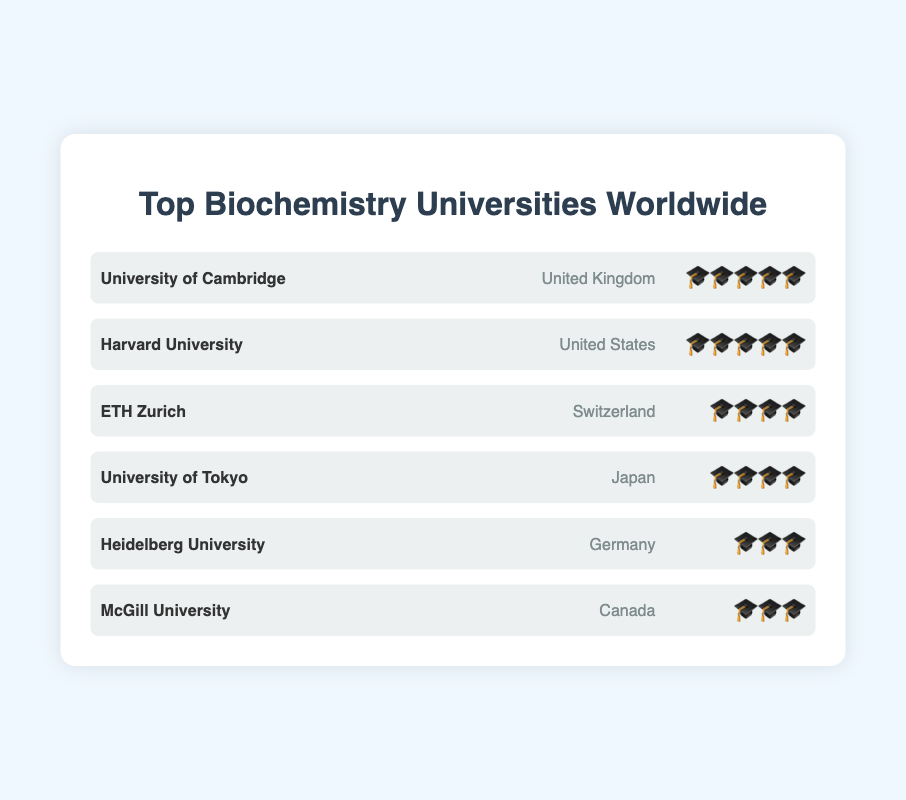Which universities have the highest rating in the chart? The chart shows two universities, University of Cambridge and Harvard University, each with a rating of 🎓🎓🎓🎓🎓. These universities have the highest ratings.
Answer: University of Cambridge and Harvard University Which university has the lowest rating on the chart? The chart indicates that both Heidelberg University and McGill University have a rating of 🎓🎓🎓. No universities have fewer graduation caps, making these the lowest-rated.
Answer: Heidelberg University and McGill University Which countries are represented by the top-rated universities? The top-rated universities, with 🎓🎓🎓🎓🎓, are University of Cambridge and Harvard University. Looking at their country labels, the United Kingdom and United States are represented.
Answer: United Kingdom and United States Which university from Japan is included in the chart, and what is its rating? The chart lists the University of Tokyo as the university from Japan. Its rating is displayed with four graduation caps 🎓🎓🎓🎓.
Answer: University of Tokyo, 🎓🎓🎓🎓 How many universities are shown on the chart in total? By counting each university row listed in the chart, there are six universities in total.
Answer: Six Which universities have a 4-graduation-cap rating? The chart shows two universities, ETH Zurich and University of Tokyo, each with a rating of 🎓🎓🎓🎓.
Answer: ETH Zurich and University of Tokyo Which country has the most universities listed in the chart? Each country listed has one university in the chart. There is no country with more than one university listed.
Answer: None How many universities have more than three graduation caps? By examining the graduation caps next to each university, four universities have more than three caps: University of Cambridge, Harvard University, ETH Zurich, and University of Tokyo.
Answer: Four Compare the ratings of universities from Canada and Germany. McGill University from Canada and Heidelberg University from Germany both have a rating of 🎓🎓🎓. This shows that their ratings are equal.
Answer: Equal Which European universities are included in the chart, and what are their ratings? The European universities in the chart are University of Cambridge (United Kingdom), ETH Zurich (Switzerland), and Heidelberg University (Germany). Their ratings are 🎓🎓🎓🎓🎓, 🎓🎓🎓🎓, and 🎓🎓🎓, respectively.
Answer: University of Cambridge (🎓🎓🎓🎓🎓), ETH Zurich (🎓🎓🎓🎓), Heidelberg University (🎓🎓🎓) 